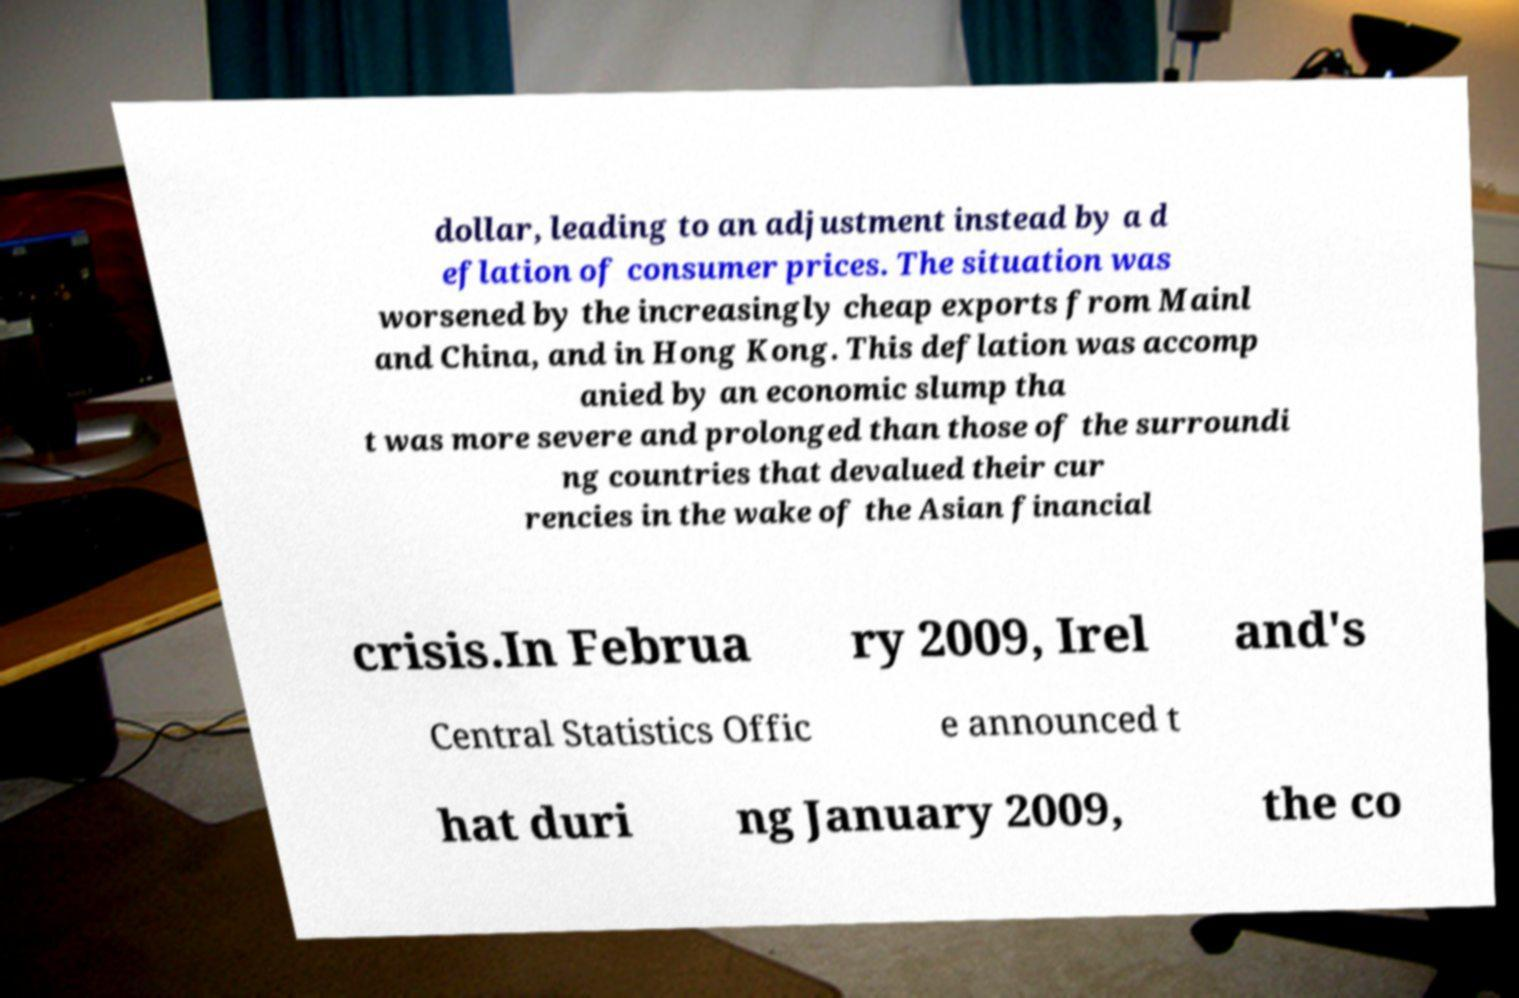Could you extract and type out the text from this image? dollar, leading to an adjustment instead by a d eflation of consumer prices. The situation was worsened by the increasingly cheap exports from Mainl and China, and in Hong Kong. This deflation was accomp anied by an economic slump tha t was more severe and prolonged than those of the surroundi ng countries that devalued their cur rencies in the wake of the Asian financial crisis.In Februa ry 2009, Irel and's Central Statistics Offic e announced t hat duri ng January 2009, the co 